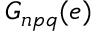<formula> <loc_0><loc_0><loc_500><loc_500>G _ { n p q } ( e )</formula> 